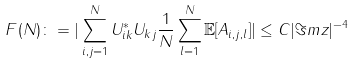Convert formula to latex. <formula><loc_0><loc_0><loc_500><loc_500>F ( N ) \colon = | \sum _ { i , j = 1 } ^ { N } U ^ { * } _ { i k } U _ { k j } \frac { 1 } { N } \sum _ { l = 1 } ^ { N } \mathbb { E } [ A _ { i , j , l } ] | \leq C | \Im m z | ^ { - 4 }</formula> 